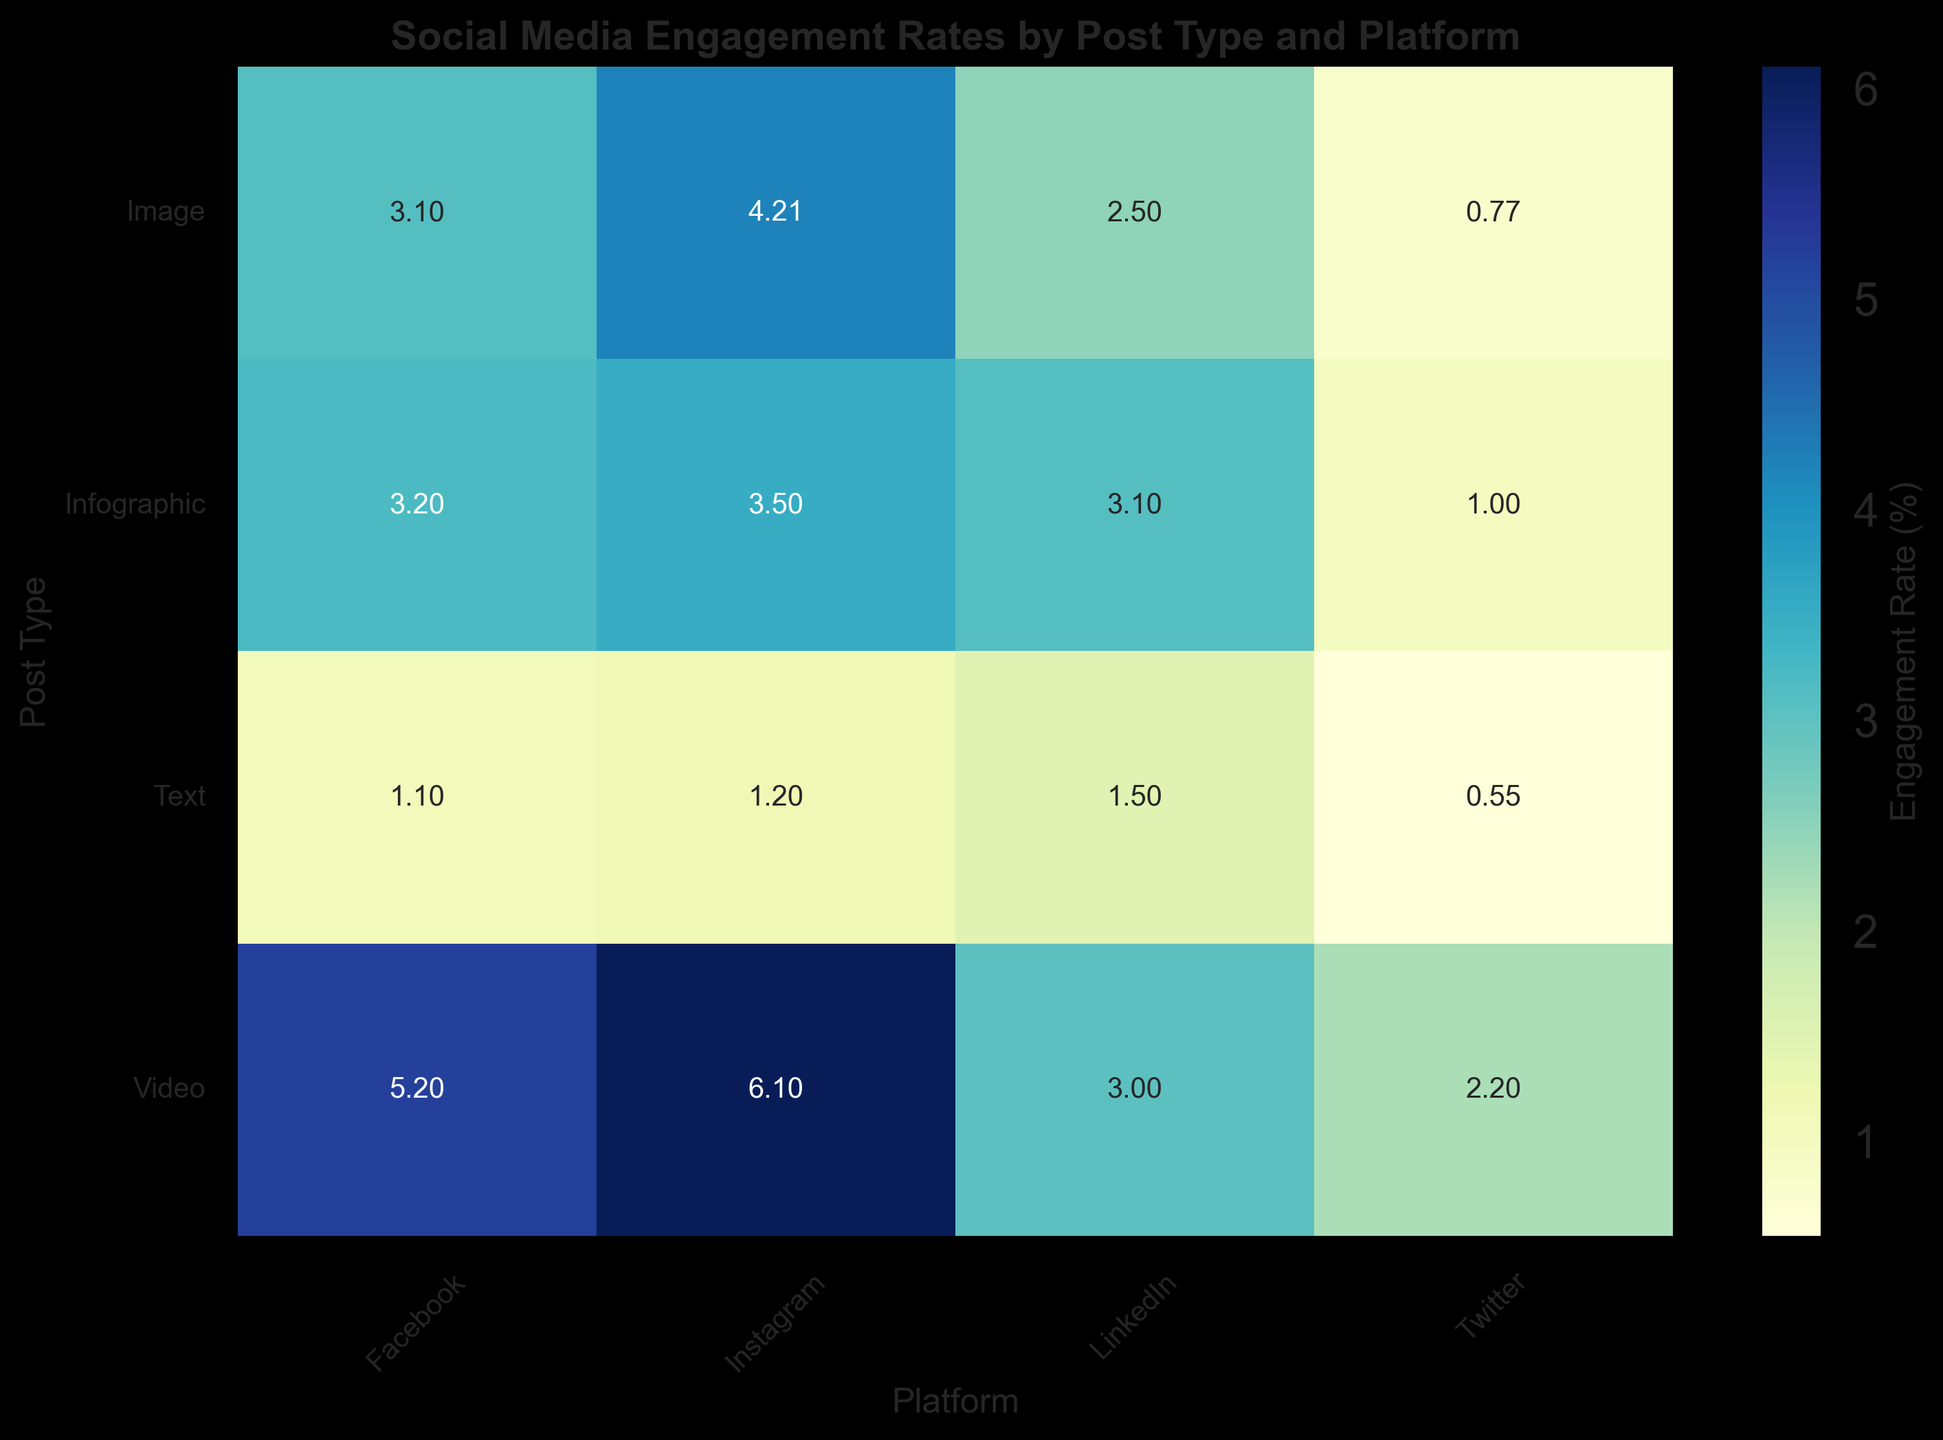Which post type has the highest engagement rate across all platforms? Look at each post type's engagement rates across all platforms and find the highest value. The post type with the highest engagement rate is "Video" on Instagram with 6.1%.
Answer: Video Do image posts on Instagram show a higher engagement rate than text posts on Instagram? Compare the engagement rates of image posts and text posts on Instagram. Image posts have a 4.21% engagement rate, while text posts have a 1.2% engagement rate. Since 4.21% is higher than 1.2%, the answer is yes.
Answer: Yes What is the average engagement rate for video posts across all platforms? Find the engagement rates for video posts on all platforms and calculate their average: (6.1 + 5.2 + 2.2 + 3.0) / 4. This gives (16.5) / 4 = 4.125. So, the average engagement rate is 4.125%.
Answer: 4.125% Which platform has the highest engagement rate for infographic posts? Look at the engagement rates for infographic posts on each platform and find the highest one. Instagram has the highest engagement rate for infographic posts with 3.5%.
Answer: Instagram Is there a platform where text posts have a higher engagement rate than video posts? Compare the engagement rates of text and video posts for each platform. Text posts on all platforms have lower engagement rates: Instagram (1.2% vs. 6.1%), Facebook (1.1% vs. 5.2%), Twitter (0.55% vs. 2.2%), LinkedIn (1.5% vs. 3.0%). So, the answer is no.
Answer: No Which post type has the lowest average engagement rate across all platforms? Calculate the average engagement rate of each post type by summing their engagement rates across platforms and dividing by the number of platforms: Image ((4.21+3.10+0.77+2.5)/4), Video ((6.1+5.2+2.2+3.0)/4), Infographic ((3.5+3.2+1.0+3.1)/4), Text ((1.2+1.1+0.55+1.5)/4). The averages are 2.645%, 4.125%, 2.7%, and 1.0875%, respectively. Text has the lowest average engagement rate.
Answer: Text On which platform do infographic posts have a higher engagement rate than video posts? Compare the engagement rates of infographic and video posts across all platforms. Infographic has higher engagement rates on no platforms compared to video: Instagram (3.5% vs. 6.1%), Facebook (3.2% vs. 5.2%), Twitter (1.0% vs. 2.2%), LinkedIn (3.1% vs. 3.0%). Hence, the answer is LinkedIn.
Answer: LinkedIn For which platform is the difference between the highest and lowest engagement rate the greatest? Find the difference between the highest and lowest engagement rates for each platform: Instagram (6.1% - 1.2% = 4.9%), Facebook (5.2% - 1.1% = 4.1%), Twitter (2.2% - 0.55% = 1.65%), LinkedIn (3.1% - 1.5% = 1.6%). Instagram has the greatest difference of 4.9%.
Answer: Instagram Which post type has the most consistent engagement rates across all platforms? Look at the engagement rates for each post type and evaluate their consistency. The differences for each post type are: Image (0.77% - 4.21% = 3.44%), Video (2.2% - 6.1% = 3.9%), Infographic (1.0% - 3.5% = 2.5%), Text (0.55% - 1.5% = 0.95%). Text posts have the most consistent engagement rates.
Answer: Text 